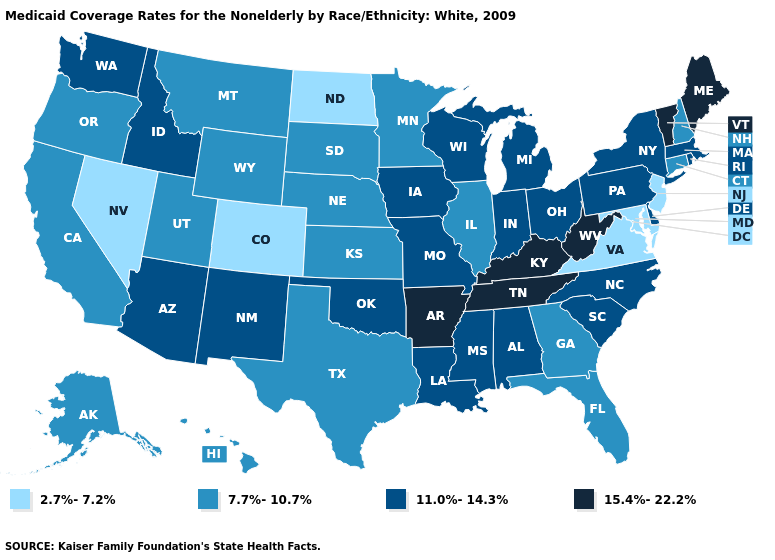What is the value of Indiana?
Be succinct. 11.0%-14.3%. What is the value of South Carolina?
Write a very short answer. 11.0%-14.3%. Does the first symbol in the legend represent the smallest category?
Concise answer only. Yes. What is the value of Maine?
Concise answer only. 15.4%-22.2%. What is the highest value in the MidWest ?
Quick response, please. 11.0%-14.3%. What is the value of Pennsylvania?
Keep it brief. 11.0%-14.3%. What is the value of Maryland?
Short answer required. 2.7%-7.2%. Name the states that have a value in the range 2.7%-7.2%?
Give a very brief answer. Colorado, Maryland, Nevada, New Jersey, North Dakota, Virginia. Does the first symbol in the legend represent the smallest category?
Short answer required. Yes. How many symbols are there in the legend?
Concise answer only. 4. What is the lowest value in the South?
Write a very short answer. 2.7%-7.2%. What is the highest value in the MidWest ?
Answer briefly. 11.0%-14.3%. Does the first symbol in the legend represent the smallest category?
Keep it brief. Yes. Name the states that have a value in the range 2.7%-7.2%?
Give a very brief answer. Colorado, Maryland, Nevada, New Jersey, North Dakota, Virginia. Does Idaho have a higher value than Georgia?
Keep it brief. Yes. 